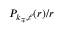<formula> <loc_0><loc_0><loc_500><loc_500>{ P _ { k _ { \mp } , \ell } ( r ) / r }</formula> 